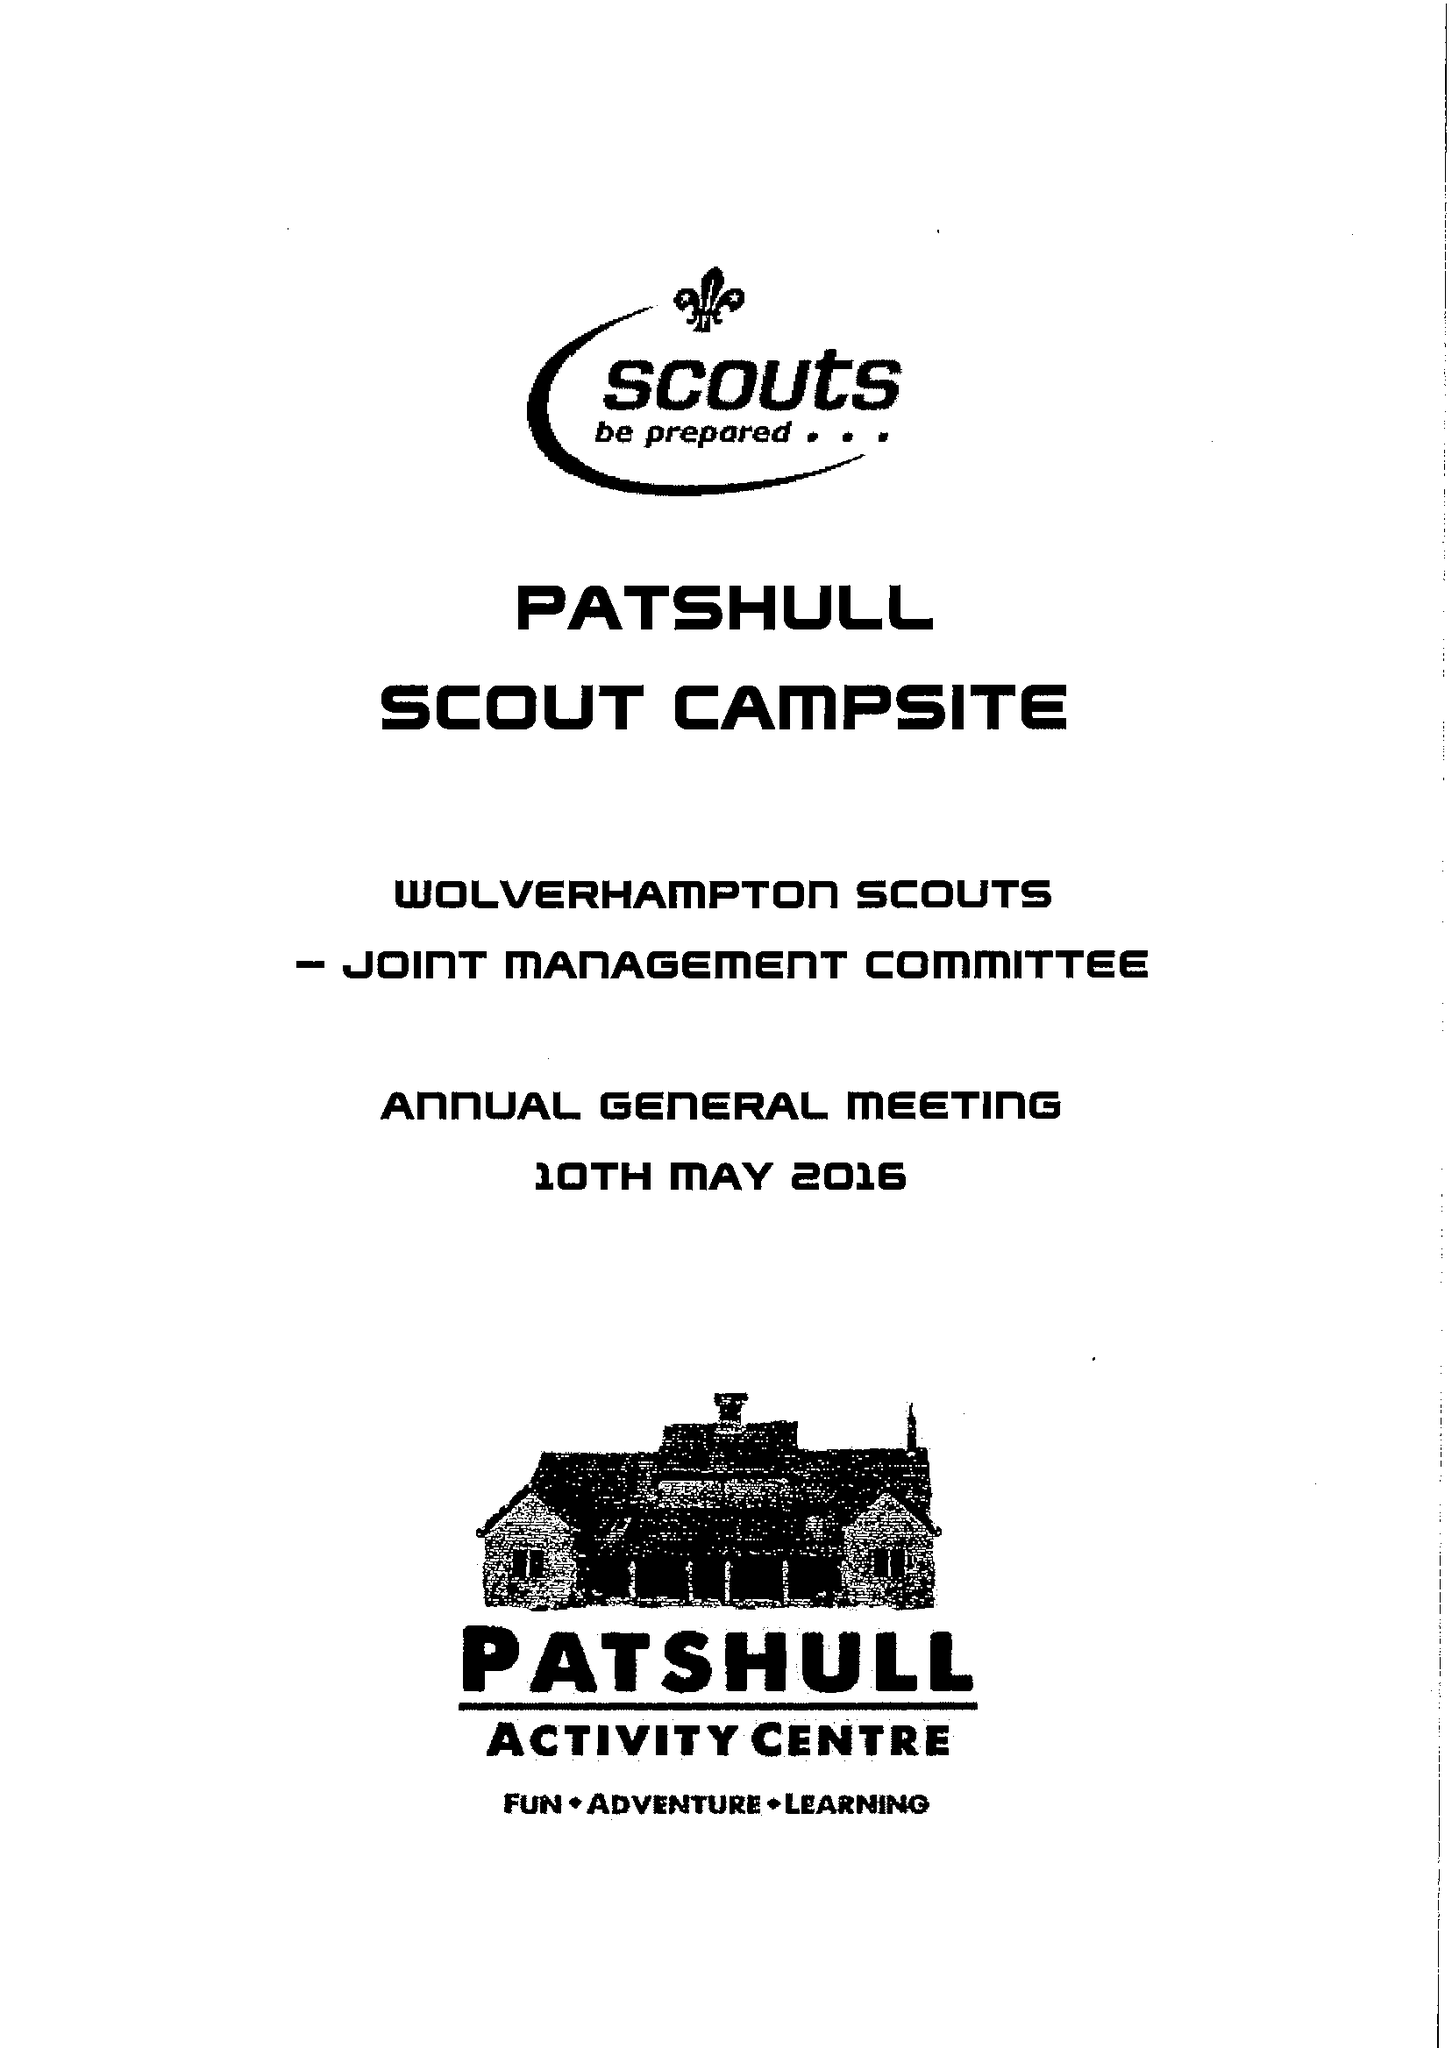What is the value for the address__street_line?
Answer the question using a single word or phrase. 32A WOOD END ROAD 